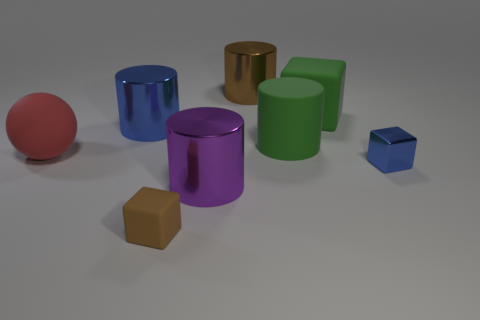Can you describe the arrangement of the objects on the surface? Certainly! The objects are arranged seemingly at random across a light surface. We have a series of cylinders and cubes in different colors, such as blue, green, purple, and gold, as well as a single red sphere. The cylinders are standing upright, and the cubes are resting on one of their faces. 